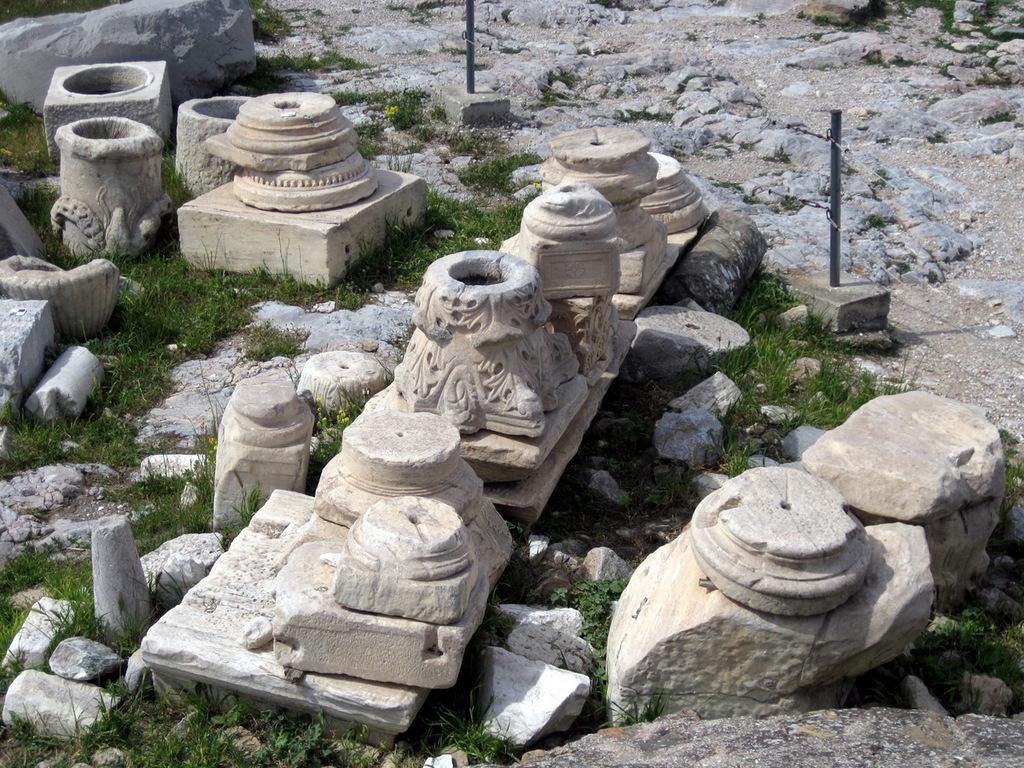What type of artwork can be seen in the image? There are sculptures in the image. What is located in front of the sculptures? Fencing is present in front of the sculptures. What is the opinion of the sculptures on the topic of debt in the image? Sculptures are inanimate objects and cannot have opinions, so this question cannot be answered. 